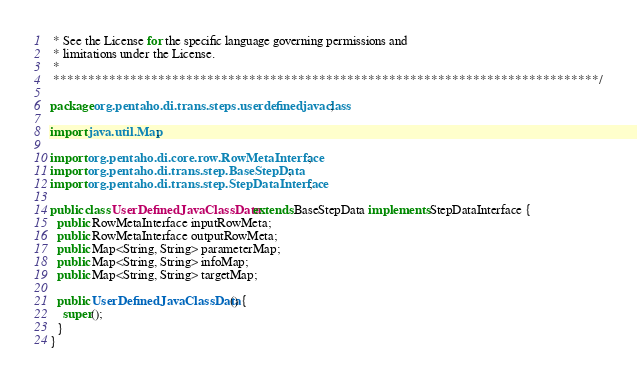Convert code to text. <code><loc_0><loc_0><loc_500><loc_500><_Java_> * See the License for the specific language governing permissions and
 * limitations under the License.
 *
 ******************************************************************************/

package org.pentaho.di.trans.steps.userdefinedjavaclass;

import java.util.Map;

import org.pentaho.di.core.row.RowMetaInterface;
import org.pentaho.di.trans.step.BaseStepData;
import org.pentaho.di.trans.step.StepDataInterface;

public class UserDefinedJavaClassData extends BaseStepData implements StepDataInterface {
  public RowMetaInterface inputRowMeta;
  public RowMetaInterface outputRowMeta;
  public Map<String, String> parameterMap;
  public Map<String, String> infoMap;
  public Map<String, String> targetMap;

  public UserDefinedJavaClassData() {
    super();
  }
}
</code> 